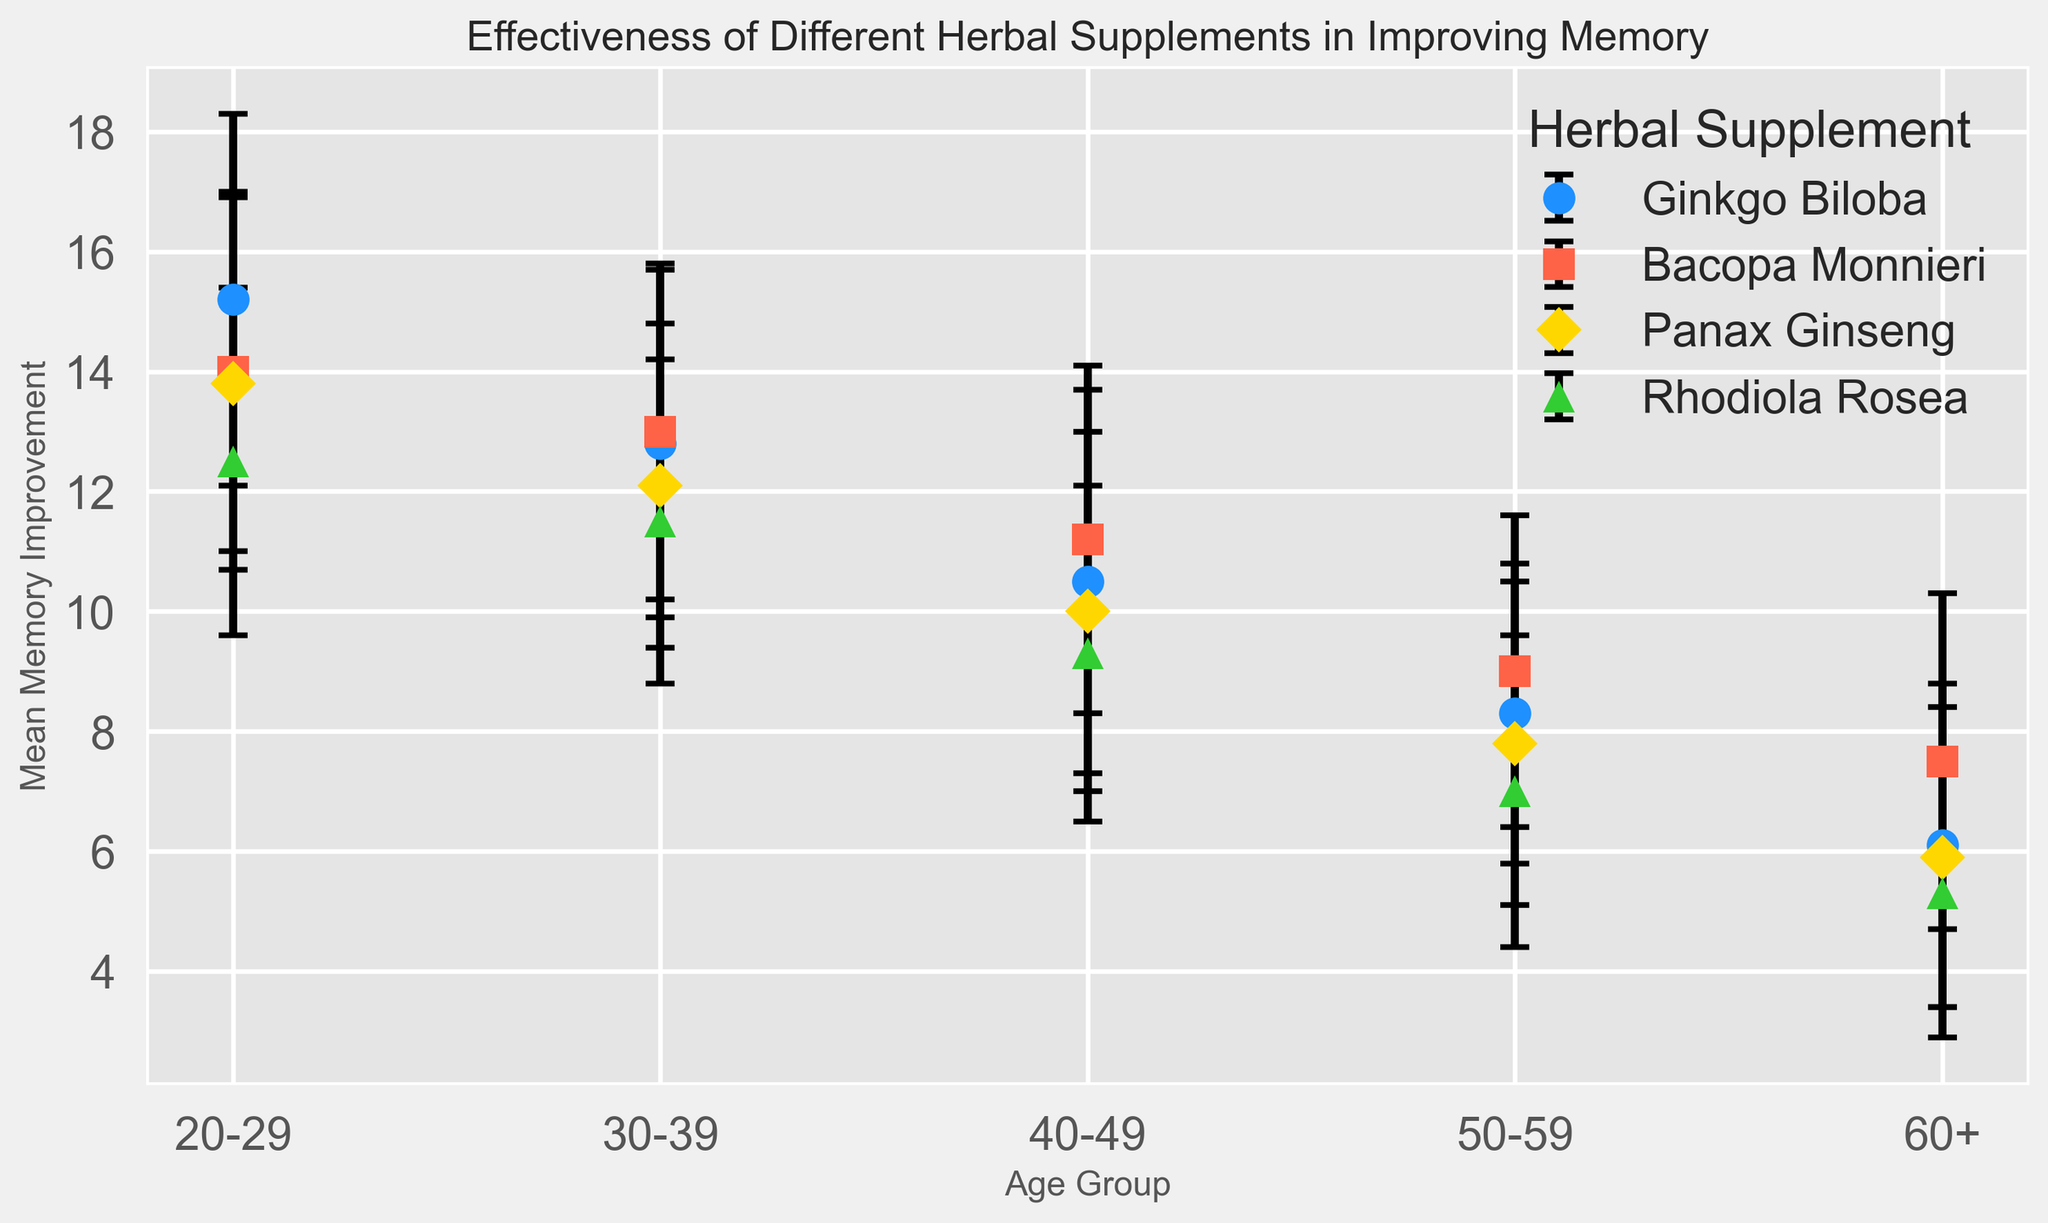What herbal supplement is most effective for the 20-29 age group? The chart shows the mean memory improvement for each supplement in different age groups. For the 20-29 age group, the highest mean memory improvement is associated with Ginkgo Biloba, with a value of 15.2.
Answer: Ginkgo Biloba Which age group benefits the least from Panax Ginseng? The plot displays mean memory improvement for Panax Ginseng across all age groups. The 60+ age group shows the lowest improvement with a mean value of 5.9.
Answer: 60+ For the 40-49 age group, how does Ginkgo Biloba's effectiveness compare to Bacopa Monnieri's effectiveness? Look at the mean memory improvement values for both supplements in the 40-49 age group. Ginkgo Biloba has a mean of 10.5, while Bacopa Monnieri has a mean of 11.2, so Bacopa Monnieri is slightly more effective.
Answer: Bacopa Monnieri is more effective Which supplements show a consistent decline in effectiveness with increasing age? By examining the trend lines for each supplement, Ginkgo Biloba, Bacopa Monnieri, Panax Ginseng, and Rhodiola Rosea all show a general decline in mean memory improvement as age increases.
Answer: All listed supplements What is the average mean memory improvement for Bacopa Monnieri across all age groups? Sum the mean memory improvement values for Bacopa Monnieri across all age groups and then divide by the number of age groups: (14.0 + 13.0 + 11.2 + 9.0 + 7.5) / 5 = 54.7 / 5 = 10.94.
Answer: 10.94 Which herbal supplement has the largest error bar in the 50-59 age group? Error bars represent the standard deviation. In the 50-59 age group, Ginkgo Biloba and Panax Ginseng both have the largest error bars with a standard deviation of 2.7.
Answer: Ginkgo Biloba and Panax Ginseng Among the 30-39 age group, which supplement shows the smallest standard deviation? Look at the standard deviation values for the 30-39 age group. Panax Ginseng has the smallest standard deviation of 2.7 in this age group.
Answer: Panax Ginseng How does the mean memory improvement of Rhodiola Rosea for the 20-29 age group compare to the 60+ age group, both in terms of absolute values and percentage decrease? Rhodiola Rosea has a mean memory improvement of 12.5 for the 20-29 age group and 5.3 for the 60+ group. The absolute difference is 12.5 - 5.3 = 7.2. For percentage decrease, calculate (12.5 - 5.3) / 12.5 * 100 = 57.6%.
Answer: 7.2 improvement, 57.6% decrease 